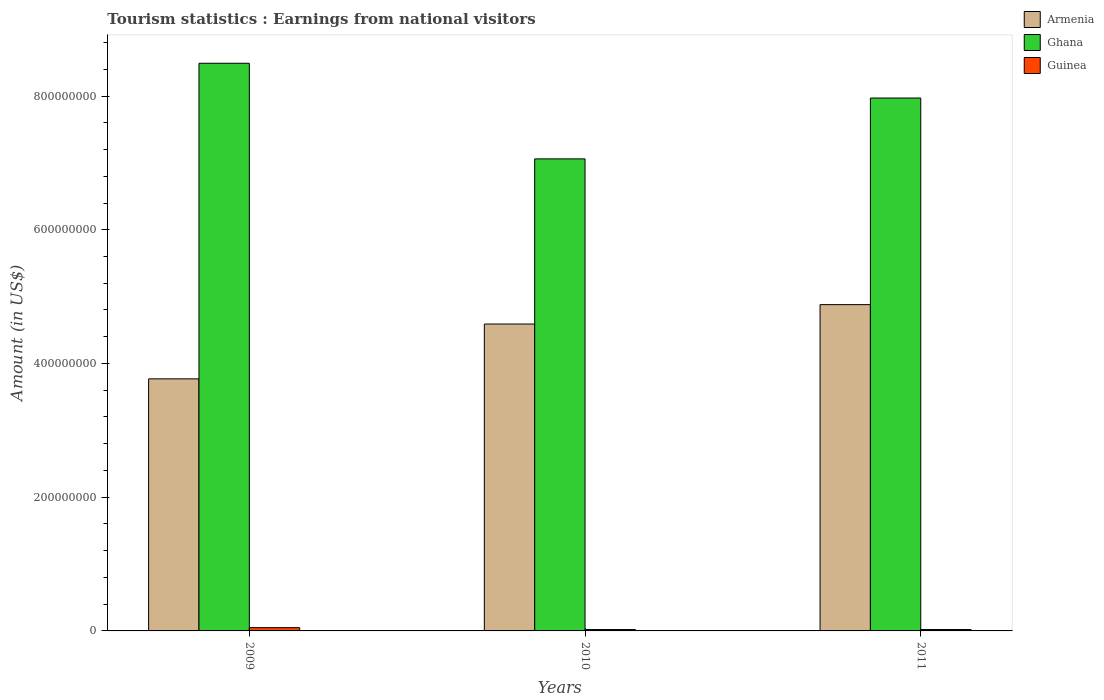How many different coloured bars are there?
Your response must be concise. 3. How many groups of bars are there?
Your answer should be compact. 3. Are the number of bars per tick equal to the number of legend labels?
Your answer should be very brief. Yes. Are the number of bars on each tick of the X-axis equal?
Your answer should be compact. Yes. How many bars are there on the 3rd tick from the left?
Your answer should be very brief. 3. What is the label of the 2nd group of bars from the left?
Your answer should be compact. 2010. In how many cases, is the number of bars for a given year not equal to the number of legend labels?
Your answer should be compact. 0. What is the earnings from national visitors in Armenia in 2011?
Give a very brief answer. 4.88e+08. Across all years, what is the maximum earnings from national visitors in Ghana?
Provide a short and direct response. 8.49e+08. Across all years, what is the minimum earnings from national visitors in Armenia?
Offer a very short reply. 3.77e+08. In which year was the earnings from national visitors in Armenia maximum?
Offer a terse response. 2011. In which year was the earnings from national visitors in Guinea minimum?
Your answer should be compact. 2010. What is the total earnings from national visitors in Guinea in the graph?
Your response must be concise. 9.06e+06. What is the difference between the earnings from national visitors in Ghana in 2010 and that in 2011?
Make the answer very short. -9.10e+07. What is the difference between the earnings from national visitors in Guinea in 2010 and the earnings from national visitors in Armenia in 2009?
Provide a short and direct response. -3.75e+08. What is the average earnings from national visitors in Ghana per year?
Offer a terse response. 7.84e+08. In the year 2010, what is the difference between the earnings from national visitors in Armenia and earnings from national visitors in Ghana?
Offer a terse response. -2.47e+08. What is the ratio of the earnings from national visitors in Armenia in 2010 to that in 2011?
Ensure brevity in your answer.  0.94. What is the difference between the highest and the second highest earnings from national visitors in Armenia?
Give a very brief answer. 2.90e+07. What is the difference between the highest and the lowest earnings from national visitors in Ghana?
Your response must be concise. 1.43e+08. In how many years, is the earnings from national visitors in Ghana greater than the average earnings from national visitors in Ghana taken over all years?
Your response must be concise. 2. Is the sum of the earnings from national visitors in Ghana in 2009 and 2010 greater than the maximum earnings from national visitors in Armenia across all years?
Provide a succinct answer. Yes. What does the 2nd bar from the left in 2010 represents?
Your answer should be compact. Ghana. What does the 2nd bar from the right in 2011 represents?
Give a very brief answer. Ghana. Is it the case that in every year, the sum of the earnings from national visitors in Ghana and earnings from national visitors in Armenia is greater than the earnings from national visitors in Guinea?
Offer a very short reply. Yes. Are the values on the major ticks of Y-axis written in scientific E-notation?
Offer a terse response. No. Where does the legend appear in the graph?
Provide a short and direct response. Top right. How are the legend labels stacked?
Offer a very short reply. Vertical. What is the title of the graph?
Your answer should be compact. Tourism statistics : Earnings from national visitors. Does "Mali" appear as one of the legend labels in the graph?
Your answer should be very brief. No. What is the label or title of the X-axis?
Provide a succinct answer. Years. What is the Amount (in US$) in Armenia in 2009?
Provide a short and direct response. 3.77e+08. What is the Amount (in US$) of Ghana in 2009?
Make the answer very short. 8.49e+08. What is the Amount (in US$) of Guinea in 2009?
Your answer should be compact. 4.90e+06. What is the Amount (in US$) in Armenia in 2010?
Ensure brevity in your answer.  4.59e+08. What is the Amount (in US$) of Ghana in 2010?
Your answer should be very brief. 7.06e+08. What is the Amount (in US$) in Guinea in 2010?
Keep it short and to the point. 2.04e+06. What is the Amount (in US$) in Armenia in 2011?
Provide a succinct answer. 4.88e+08. What is the Amount (in US$) in Ghana in 2011?
Provide a succinct answer. 7.97e+08. What is the Amount (in US$) in Guinea in 2011?
Ensure brevity in your answer.  2.12e+06. Across all years, what is the maximum Amount (in US$) of Armenia?
Your answer should be compact. 4.88e+08. Across all years, what is the maximum Amount (in US$) in Ghana?
Your answer should be very brief. 8.49e+08. Across all years, what is the maximum Amount (in US$) of Guinea?
Your response must be concise. 4.90e+06. Across all years, what is the minimum Amount (in US$) of Armenia?
Your answer should be compact. 3.77e+08. Across all years, what is the minimum Amount (in US$) of Ghana?
Offer a very short reply. 7.06e+08. Across all years, what is the minimum Amount (in US$) in Guinea?
Ensure brevity in your answer.  2.04e+06. What is the total Amount (in US$) in Armenia in the graph?
Provide a succinct answer. 1.32e+09. What is the total Amount (in US$) in Ghana in the graph?
Keep it short and to the point. 2.35e+09. What is the total Amount (in US$) in Guinea in the graph?
Offer a very short reply. 9.06e+06. What is the difference between the Amount (in US$) in Armenia in 2009 and that in 2010?
Your answer should be very brief. -8.20e+07. What is the difference between the Amount (in US$) in Ghana in 2009 and that in 2010?
Give a very brief answer. 1.43e+08. What is the difference between the Amount (in US$) in Guinea in 2009 and that in 2010?
Provide a succinct answer. 2.86e+06. What is the difference between the Amount (in US$) in Armenia in 2009 and that in 2011?
Make the answer very short. -1.11e+08. What is the difference between the Amount (in US$) in Ghana in 2009 and that in 2011?
Provide a short and direct response. 5.20e+07. What is the difference between the Amount (in US$) of Guinea in 2009 and that in 2011?
Your answer should be very brief. 2.78e+06. What is the difference between the Amount (in US$) of Armenia in 2010 and that in 2011?
Your response must be concise. -2.90e+07. What is the difference between the Amount (in US$) of Ghana in 2010 and that in 2011?
Provide a succinct answer. -9.10e+07. What is the difference between the Amount (in US$) in Guinea in 2010 and that in 2011?
Your answer should be very brief. -8.00e+04. What is the difference between the Amount (in US$) of Armenia in 2009 and the Amount (in US$) of Ghana in 2010?
Your answer should be compact. -3.29e+08. What is the difference between the Amount (in US$) in Armenia in 2009 and the Amount (in US$) in Guinea in 2010?
Make the answer very short. 3.75e+08. What is the difference between the Amount (in US$) in Ghana in 2009 and the Amount (in US$) in Guinea in 2010?
Provide a short and direct response. 8.47e+08. What is the difference between the Amount (in US$) in Armenia in 2009 and the Amount (in US$) in Ghana in 2011?
Ensure brevity in your answer.  -4.20e+08. What is the difference between the Amount (in US$) in Armenia in 2009 and the Amount (in US$) in Guinea in 2011?
Ensure brevity in your answer.  3.75e+08. What is the difference between the Amount (in US$) of Ghana in 2009 and the Amount (in US$) of Guinea in 2011?
Your response must be concise. 8.47e+08. What is the difference between the Amount (in US$) in Armenia in 2010 and the Amount (in US$) in Ghana in 2011?
Keep it short and to the point. -3.38e+08. What is the difference between the Amount (in US$) of Armenia in 2010 and the Amount (in US$) of Guinea in 2011?
Provide a succinct answer. 4.57e+08. What is the difference between the Amount (in US$) in Ghana in 2010 and the Amount (in US$) in Guinea in 2011?
Offer a terse response. 7.04e+08. What is the average Amount (in US$) of Armenia per year?
Your answer should be very brief. 4.41e+08. What is the average Amount (in US$) in Ghana per year?
Make the answer very short. 7.84e+08. What is the average Amount (in US$) in Guinea per year?
Keep it short and to the point. 3.02e+06. In the year 2009, what is the difference between the Amount (in US$) in Armenia and Amount (in US$) in Ghana?
Give a very brief answer. -4.72e+08. In the year 2009, what is the difference between the Amount (in US$) in Armenia and Amount (in US$) in Guinea?
Ensure brevity in your answer.  3.72e+08. In the year 2009, what is the difference between the Amount (in US$) in Ghana and Amount (in US$) in Guinea?
Offer a very short reply. 8.44e+08. In the year 2010, what is the difference between the Amount (in US$) in Armenia and Amount (in US$) in Ghana?
Give a very brief answer. -2.47e+08. In the year 2010, what is the difference between the Amount (in US$) of Armenia and Amount (in US$) of Guinea?
Your answer should be compact. 4.57e+08. In the year 2010, what is the difference between the Amount (in US$) in Ghana and Amount (in US$) in Guinea?
Your response must be concise. 7.04e+08. In the year 2011, what is the difference between the Amount (in US$) of Armenia and Amount (in US$) of Ghana?
Provide a succinct answer. -3.09e+08. In the year 2011, what is the difference between the Amount (in US$) of Armenia and Amount (in US$) of Guinea?
Your response must be concise. 4.86e+08. In the year 2011, what is the difference between the Amount (in US$) of Ghana and Amount (in US$) of Guinea?
Your answer should be compact. 7.95e+08. What is the ratio of the Amount (in US$) in Armenia in 2009 to that in 2010?
Keep it short and to the point. 0.82. What is the ratio of the Amount (in US$) of Ghana in 2009 to that in 2010?
Your response must be concise. 1.2. What is the ratio of the Amount (in US$) in Guinea in 2009 to that in 2010?
Your answer should be very brief. 2.4. What is the ratio of the Amount (in US$) of Armenia in 2009 to that in 2011?
Offer a very short reply. 0.77. What is the ratio of the Amount (in US$) of Ghana in 2009 to that in 2011?
Provide a succinct answer. 1.07. What is the ratio of the Amount (in US$) of Guinea in 2009 to that in 2011?
Give a very brief answer. 2.31. What is the ratio of the Amount (in US$) in Armenia in 2010 to that in 2011?
Give a very brief answer. 0.94. What is the ratio of the Amount (in US$) in Ghana in 2010 to that in 2011?
Give a very brief answer. 0.89. What is the ratio of the Amount (in US$) in Guinea in 2010 to that in 2011?
Your response must be concise. 0.96. What is the difference between the highest and the second highest Amount (in US$) of Armenia?
Offer a very short reply. 2.90e+07. What is the difference between the highest and the second highest Amount (in US$) in Ghana?
Ensure brevity in your answer.  5.20e+07. What is the difference between the highest and the second highest Amount (in US$) of Guinea?
Provide a succinct answer. 2.78e+06. What is the difference between the highest and the lowest Amount (in US$) in Armenia?
Your answer should be compact. 1.11e+08. What is the difference between the highest and the lowest Amount (in US$) of Ghana?
Offer a terse response. 1.43e+08. What is the difference between the highest and the lowest Amount (in US$) in Guinea?
Keep it short and to the point. 2.86e+06. 